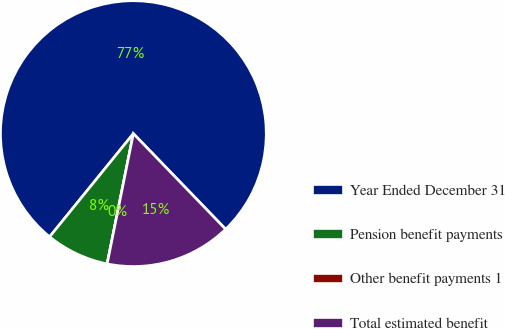Convert chart to OTSL. <chart><loc_0><loc_0><loc_500><loc_500><pie_chart><fcel>Year Ended December 31<fcel>Pension benefit payments<fcel>Other benefit payments 1<fcel>Total estimated benefit<nl><fcel>76.92%<fcel>7.69%<fcel>0.0%<fcel>15.38%<nl></chart> 